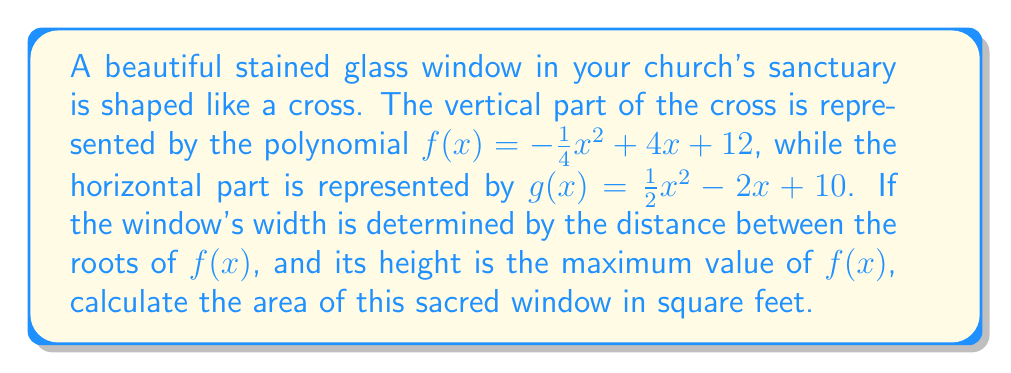Help me with this question. Let's approach this step-by-step:

1) First, we need to find the roots of $f(x)$ to determine the width:
   $f(x) = -\frac{1}{4}x^2 + 4x + 12 = 0$
   Using the quadratic formula: $x = \frac{-b \pm \sqrt{b^2 - 4ac}}{2a}$
   $x = \frac{-4 \pm \sqrt{16 + 12}}{-\frac{1}{2}} = 8 \pm \sqrt{28}$

2) The roots are $x_1 = 8 + \sqrt{28}$ and $x_2 = 8 - \sqrt{28}$
   The width is the distance between these roots:
   $width = (8 + \sqrt{28}) - (8 - \sqrt{28}) = 2\sqrt{28} \approx 10.58$ feet

3) To find the height, we need the maximum value of $f(x)$:
   The vertex of a parabola occurs at $x = -\frac{b}{2a}$
   Here, $x = -\frac{4}{2(-\frac{1}{4})} = 8$

4) The maximum height is $f(8)$:
   $f(8) = -\frac{1}{4}(8)^2 + 4(8) + 12 = -16 + 32 + 12 = 28$ feet

5) The area of the window is width * height:
   $Area = 2\sqrt{28} * 28 \approx 296.24$ square feet
Answer: $296.24$ sq ft 